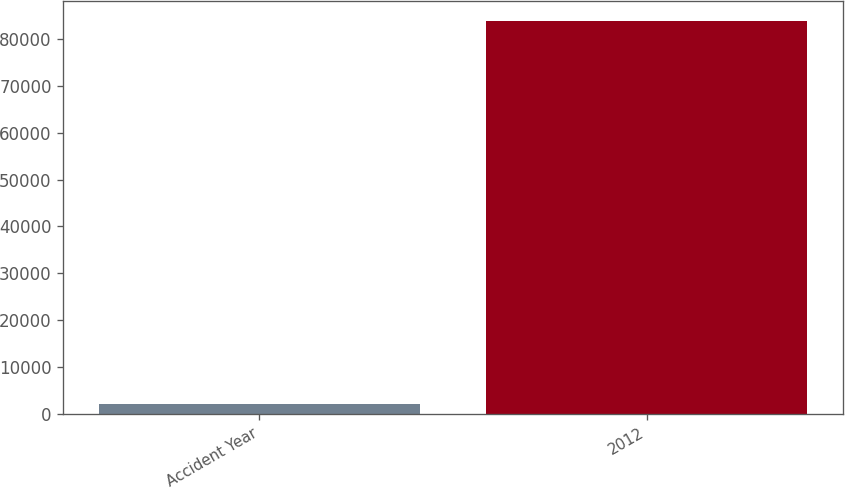Convert chart. <chart><loc_0><loc_0><loc_500><loc_500><bar_chart><fcel>Accident Year<fcel>2012<nl><fcel>2015<fcel>83906<nl></chart> 